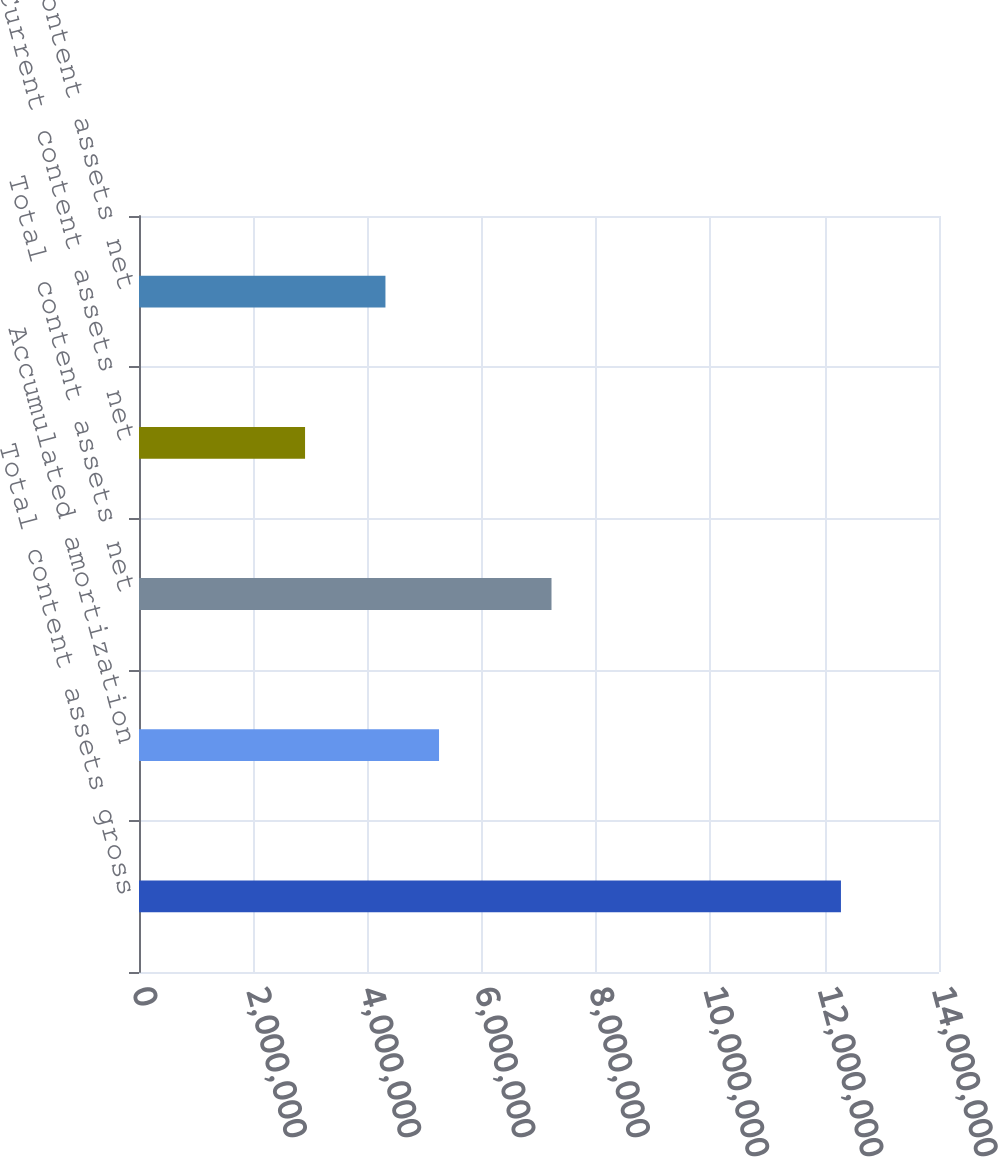Convert chart to OTSL. <chart><loc_0><loc_0><loc_500><loc_500><bar_chart><fcel>Total content assets gross<fcel>Accumulated amortization<fcel>Total content assets net<fcel>Current content assets net<fcel>Non-current content assets net<nl><fcel>1.22841e+07<fcel>5.25063e+06<fcel>7.21882e+06<fcel>2.906e+06<fcel>4.31282e+06<nl></chart> 